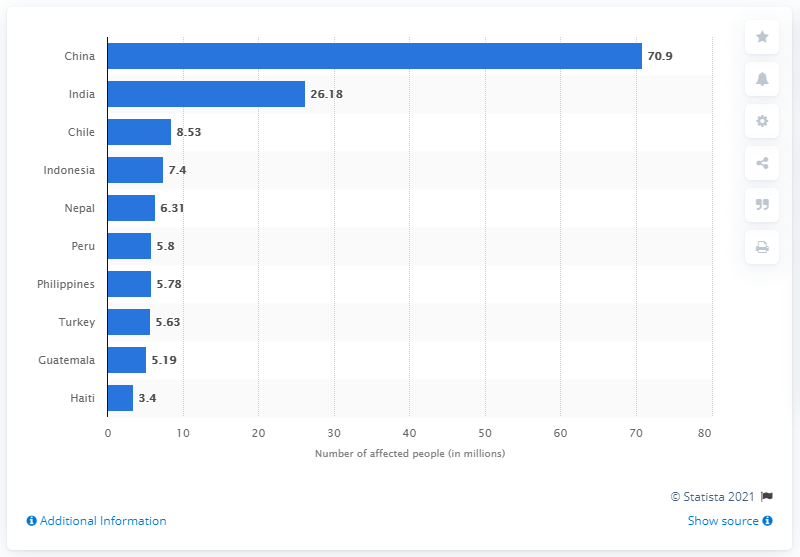What does the chart reveal about India's situation with earthquakes? The chart shows that about 26.18 million people in India were affected by earthquakes in the same period. Though significantly lower than China's figure, it still represents a major impact, necessitating effective disaster management and mitigation strategies in India. 